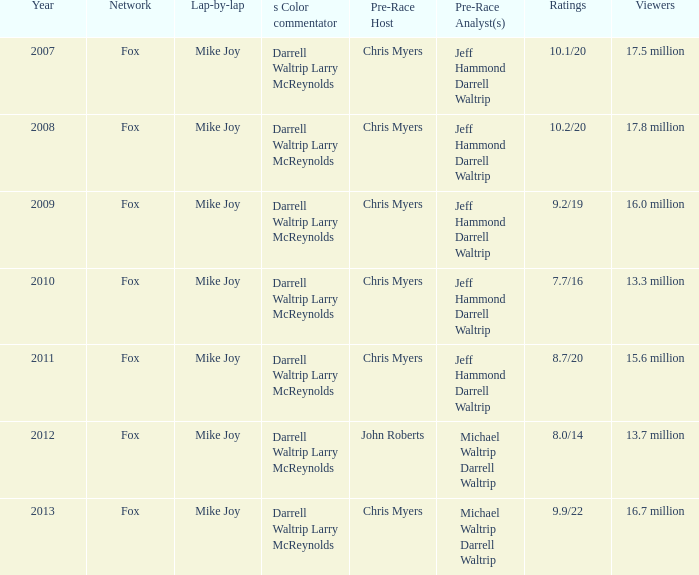0 million audience members? Fox. 